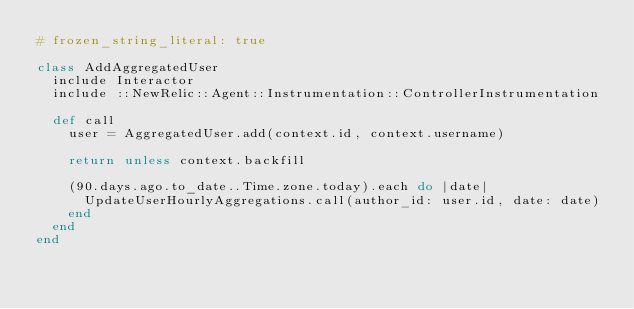<code> <loc_0><loc_0><loc_500><loc_500><_Ruby_># frozen_string_literal: true

class AddAggregatedUser
  include Interactor
  include ::NewRelic::Agent::Instrumentation::ControllerInstrumentation

  def call
    user = AggregatedUser.add(context.id, context.username)

    return unless context.backfill

    (90.days.ago.to_date..Time.zone.today).each do |date|
      UpdateUserHourlyAggregations.call(author_id: user.id, date: date)
    end
  end
end
</code> 